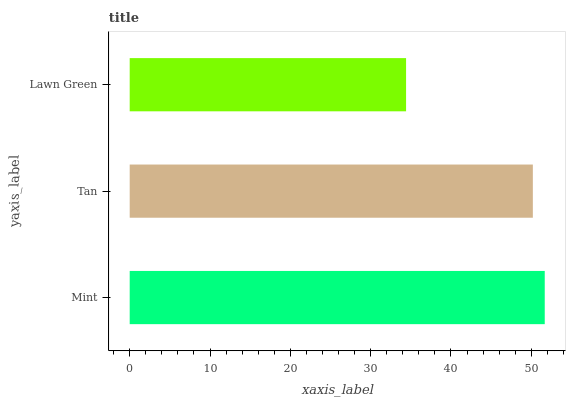Is Lawn Green the minimum?
Answer yes or no. Yes. Is Mint the maximum?
Answer yes or no. Yes. Is Tan the minimum?
Answer yes or no. No. Is Tan the maximum?
Answer yes or no. No. Is Mint greater than Tan?
Answer yes or no. Yes. Is Tan less than Mint?
Answer yes or no. Yes. Is Tan greater than Mint?
Answer yes or no. No. Is Mint less than Tan?
Answer yes or no. No. Is Tan the high median?
Answer yes or no. Yes. Is Tan the low median?
Answer yes or no. Yes. Is Mint the high median?
Answer yes or no. No. Is Mint the low median?
Answer yes or no. No. 